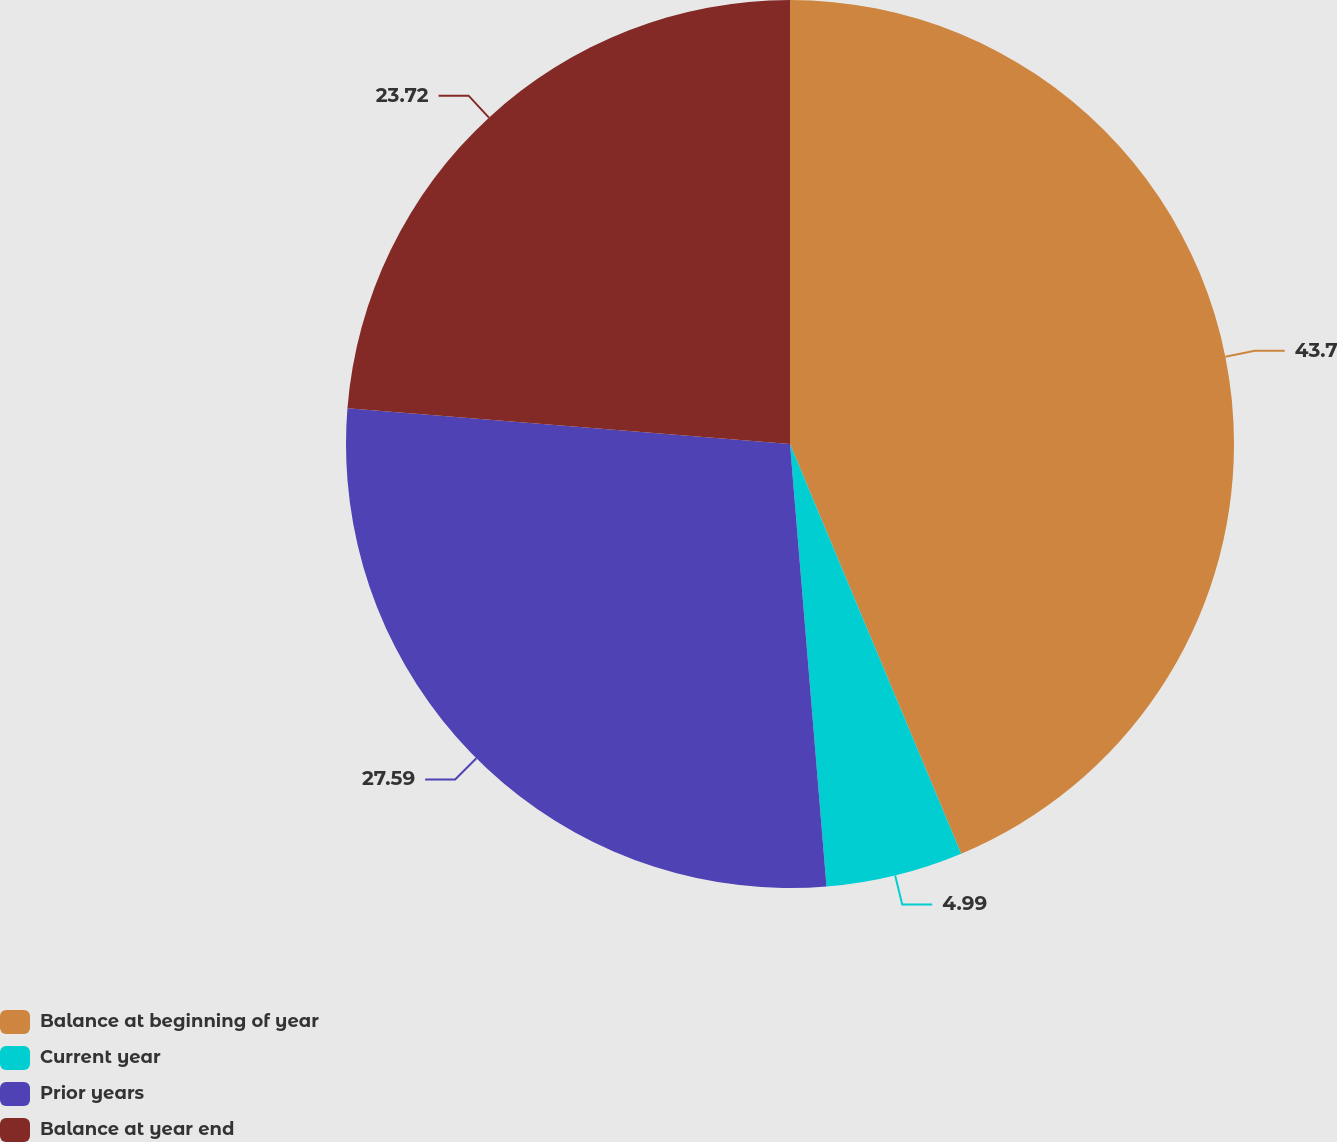Convert chart. <chart><loc_0><loc_0><loc_500><loc_500><pie_chart><fcel>Balance at beginning of year<fcel>Current year<fcel>Prior years<fcel>Balance at year end<nl><fcel>43.7%<fcel>4.99%<fcel>27.59%<fcel>23.72%<nl></chart> 